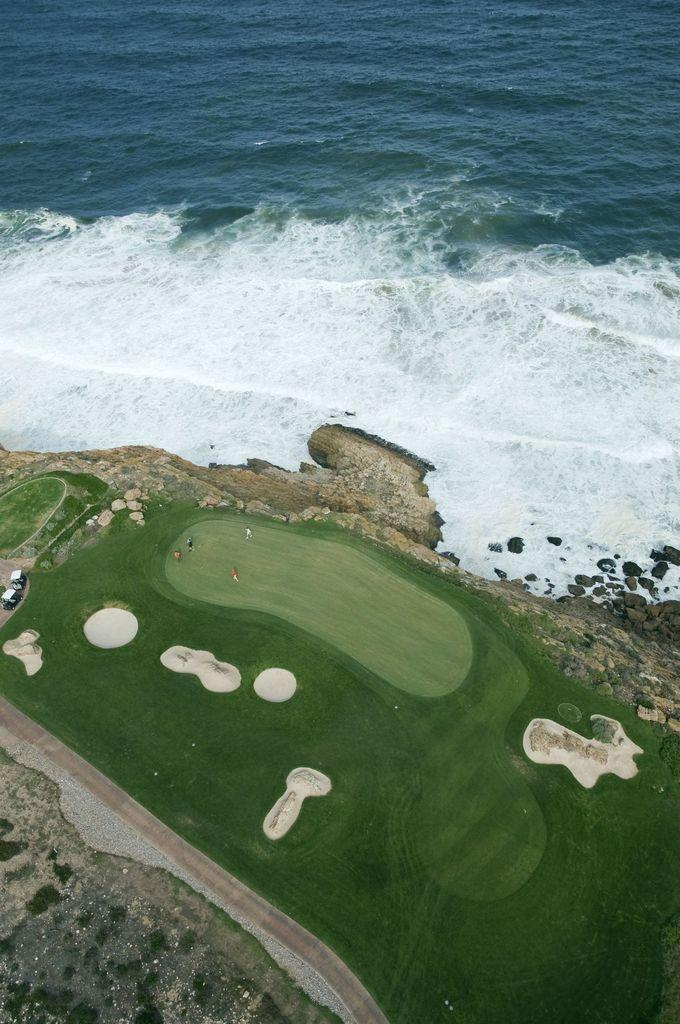What natural feature is visible in the image? The image contains the ocean. How was the image captured? The image is an example of aerial photography. What can be seen on the left side of the image? There are vehicles on the left side of the image. How many nails are visible in the image? There are no nails present in the image. What type of iron can be seen in the image? There is no iron present in the image. 